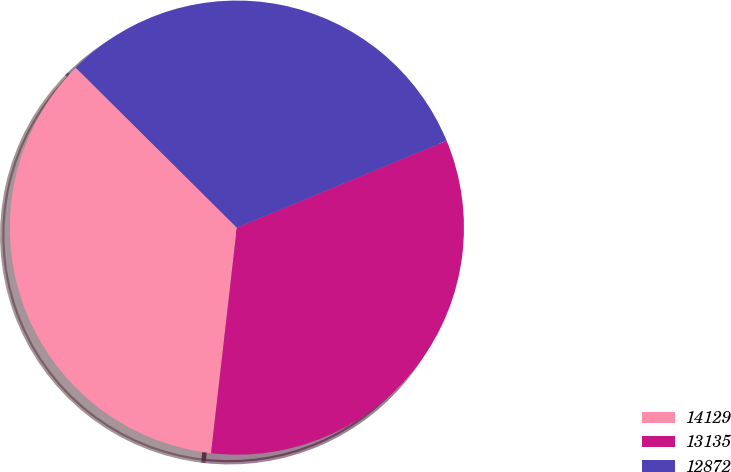Convert chart to OTSL. <chart><loc_0><loc_0><loc_500><loc_500><pie_chart><fcel>14129<fcel>13135<fcel>12872<nl><fcel>35.63%<fcel>33.07%<fcel>31.3%<nl></chart> 